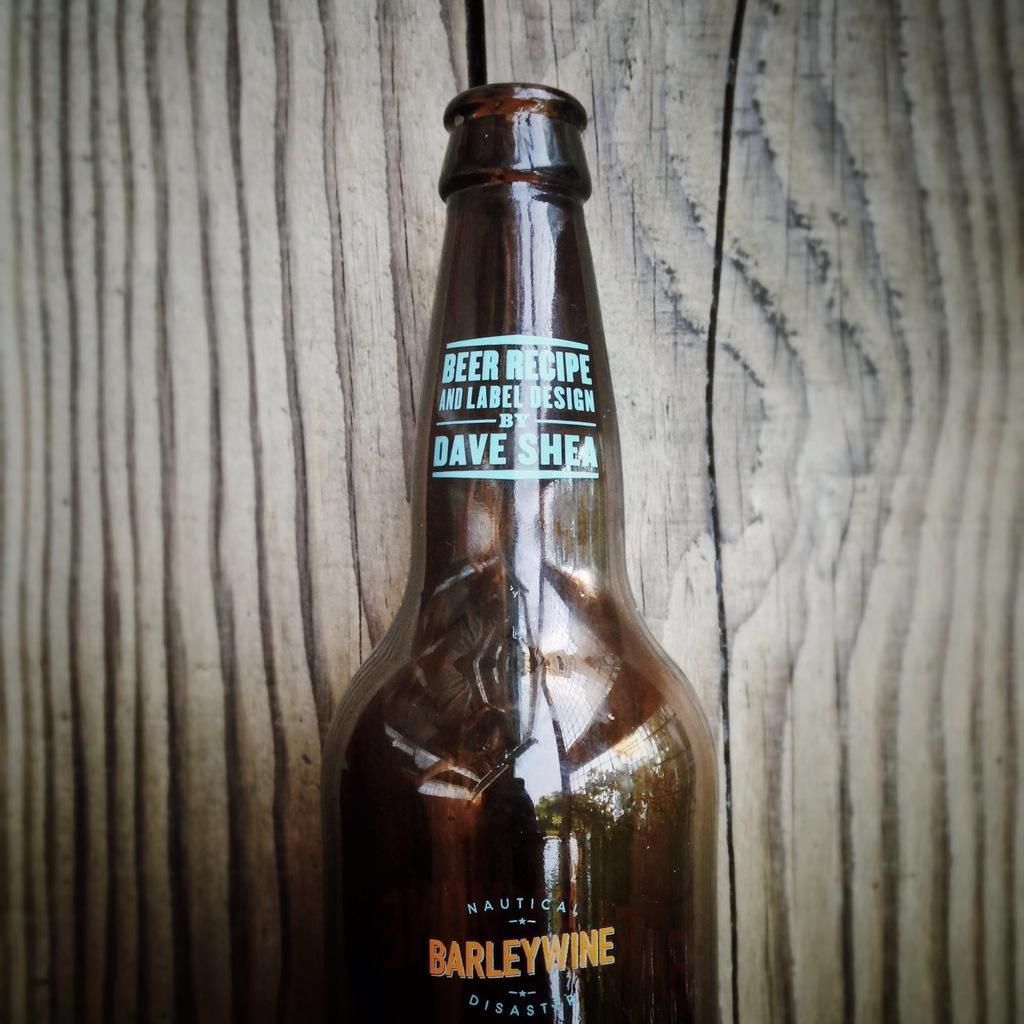<image>
Provide a brief description of the given image. bottle of barleywine in front of wooden background 